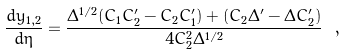Convert formula to latex. <formula><loc_0><loc_0><loc_500><loc_500>\frac { d y _ { 1 , 2 } } { d \eta } = \frac { \Delta ^ { 1 / 2 } ( C _ { 1 } C _ { 2 } ^ { \prime } - C _ { 2 } C _ { 1 } ^ { \prime } ) + ( C _ { 2 } \Delta ^ { \prime } - \Delta C _ { 2 } ^ { \prime } ) } { 4 C _ { 2 } ^ { 2 } \Delta ^ { 1 / 2 } } \ ,</formula> 